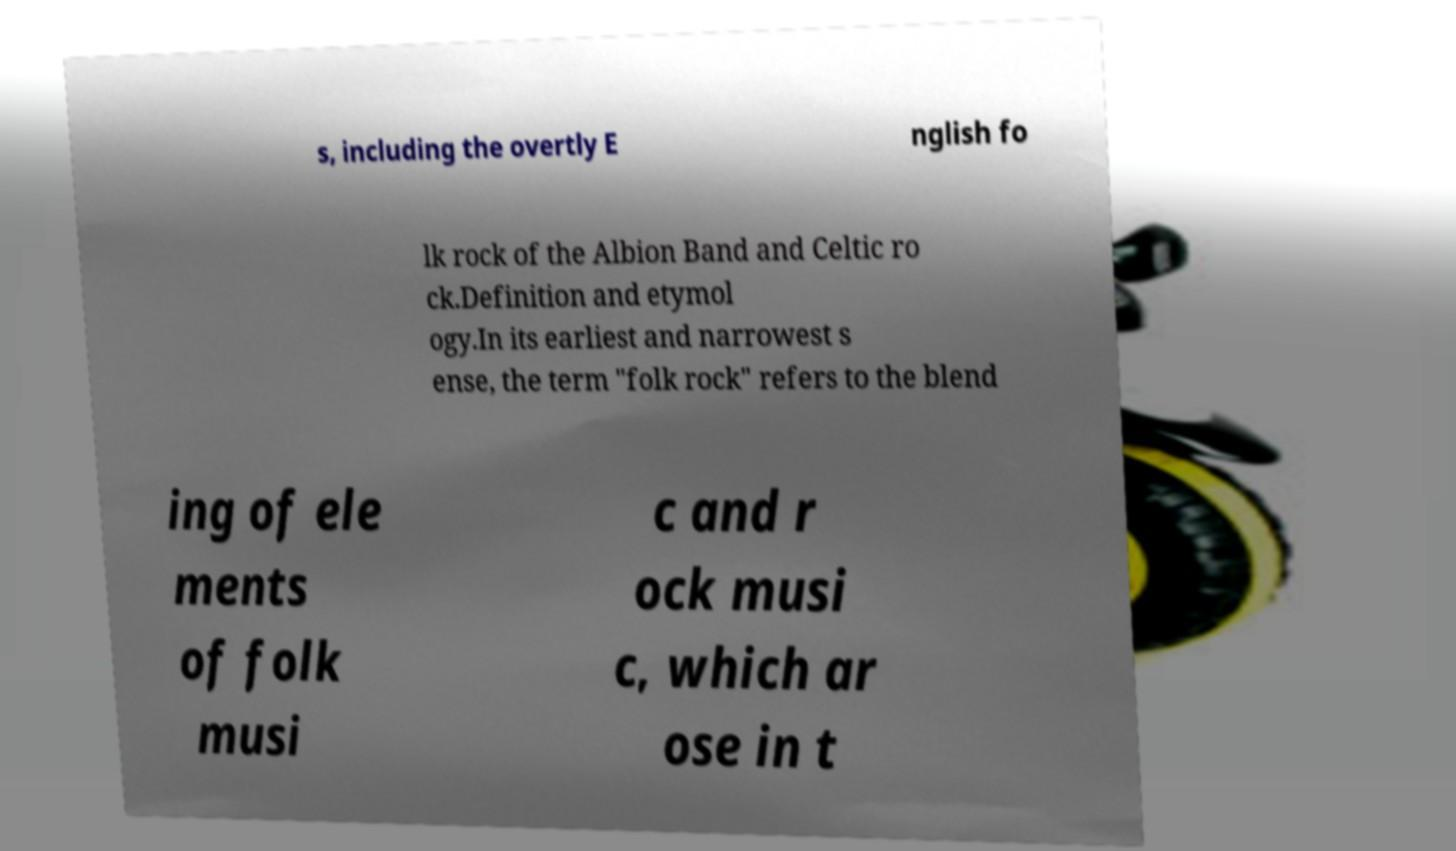Can you accurately transcribe the text from the provided image for me? s, including the overtly E nglish fo lk rock of the Albion Band and Celtic ro ck.Definition and etymol ogy.In its earliest and narrowest s ense, the term "folk rock" refers to the blend ing of ele ments of folk musi c and r ock musi c, which ar ose in t 